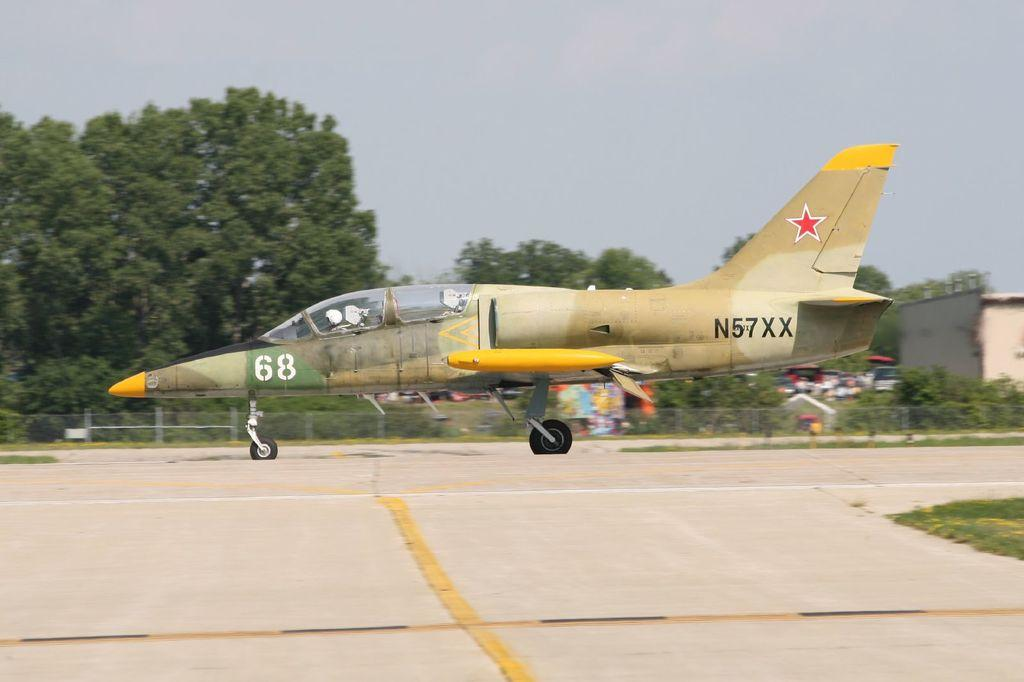What is the main subject of the image? The main subject of the image is a flying jet. Can you describe the person inside the jet? A person is sitting inside the jet. What can be seen on the ground in the image? There is a road visible in the image, along with grass, vehicles, a fence, and trees. What is visible in the background of the image? The sky is visible in the image. How many frogs are sitting on the tub in the image? There is no tub or frogs present in the image. What type of cave can be seen in the image? There is no cave present in the image. 